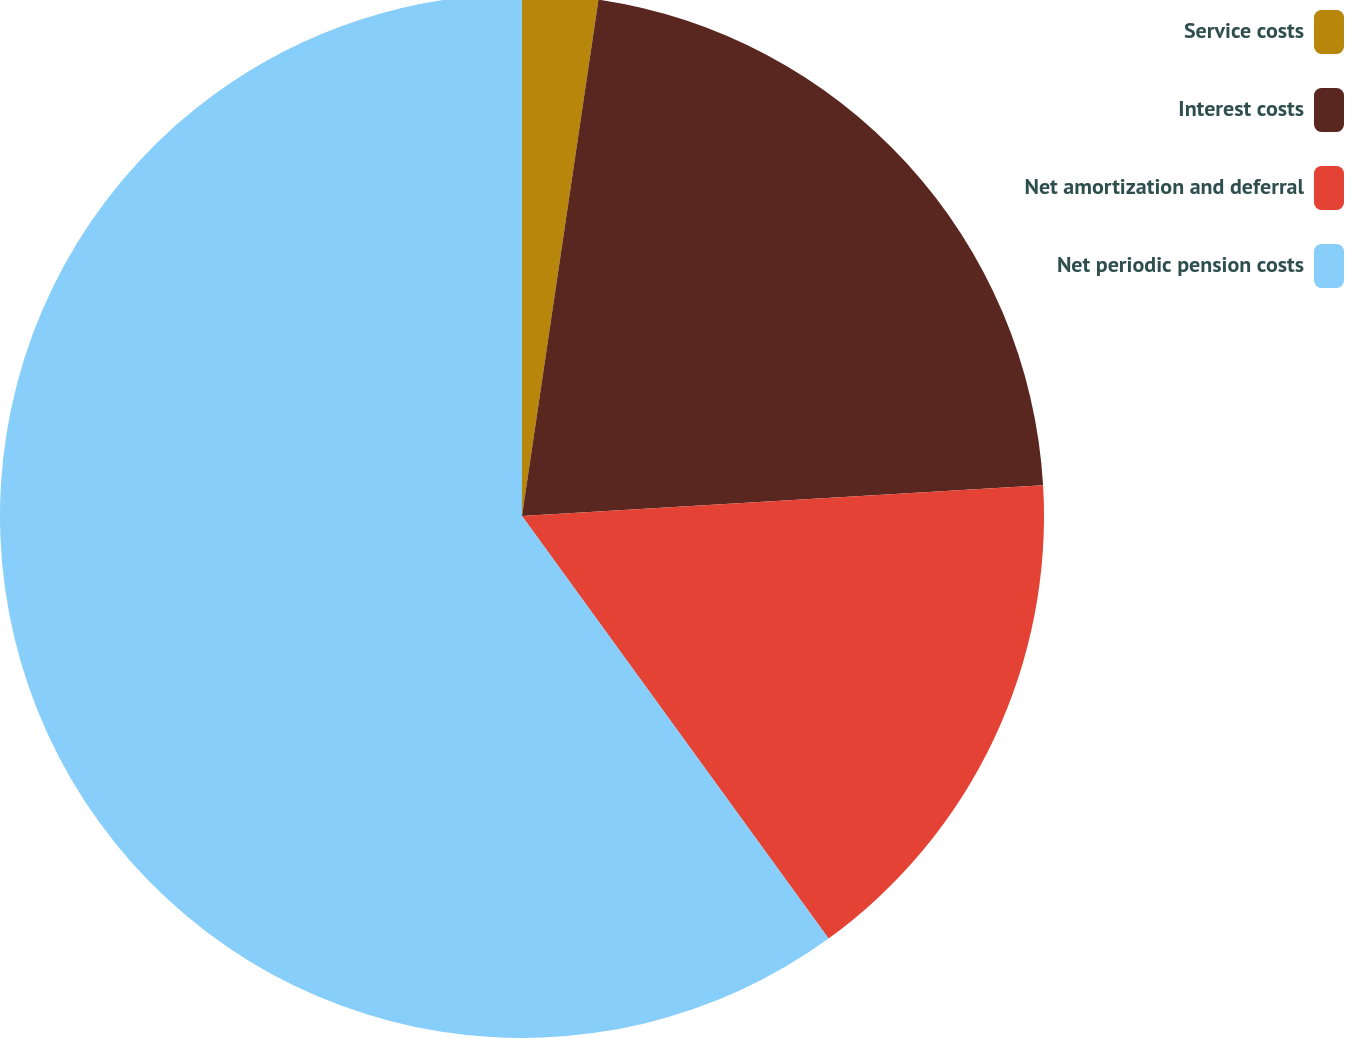<chart> <loc_0><loc_0><loc_500><loc_500><pie_chart><fcel>Service costs<fcel>Interest costs<fcel>Net amortization and deferral<fcel>Net periodic pension costs<nl><fcel>2.34%<fcel>21.72%<fcel>15.95%<fcel>59.99%<nl></chart> 